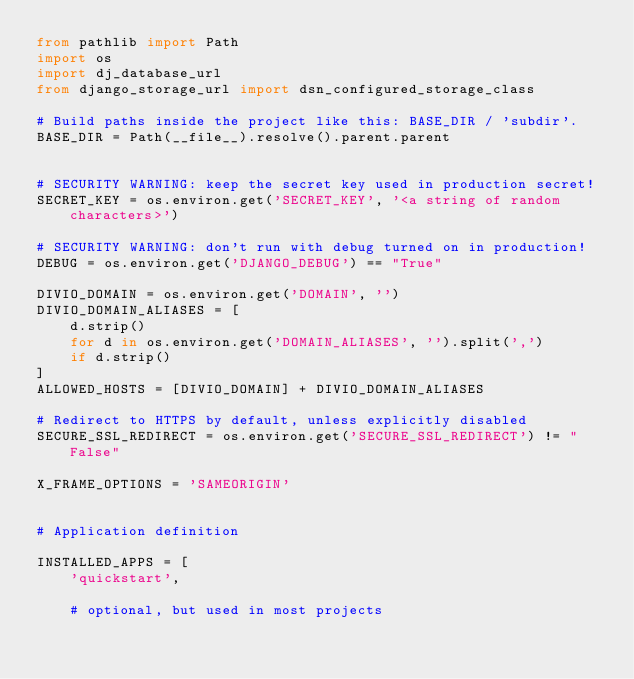<code> <loc_0><loc_0><loc_500><loc_500><_Python_>from pathlib import Path
import os
import dj_database_url
from django_storage_url import dsn_configured_storage_class

# Build paths inside the project like this: BASE_DIR / 'subdir'.
BASE_DIR = Path(__file__).resolve().parent.parent


# SECURITY WARNING: keep the secret key used in production secret!
SECRET_KEY = os.environ.get('SECRET_KEY', '<a string of random characters>')

# SECURITY WARNING: don't run with debug turned on in production!
DEBUG = os.environ.get('DJANGO_DEBUG') == "True"

DIVIO_DOMAIN = os.environ.get('DOMAIN', '')
DIVIO_DOMAIN_ALIASES = [
    d.strip()
    for d in os.environ.get('DOMAIN_ALIASES', '').split(',')
    if d.strip()
]
ALLOWED_HOSTS = [DIVIO_DOMAIN] + DIVIO_DOMAIN_ALIASES

# Redirect to HTTPS by default, unless explicitly disabled
SECURE_SSL_REDIRECT = os.environ.get('SECURE_SSL_REDIRECT') != "False"

X_FRAME_OPTIONS = 'SAMEORIGIN'


# Application definition

INSTALLED_APPS = [
    'quickstart',

    # optional, but used in most projects</code> 